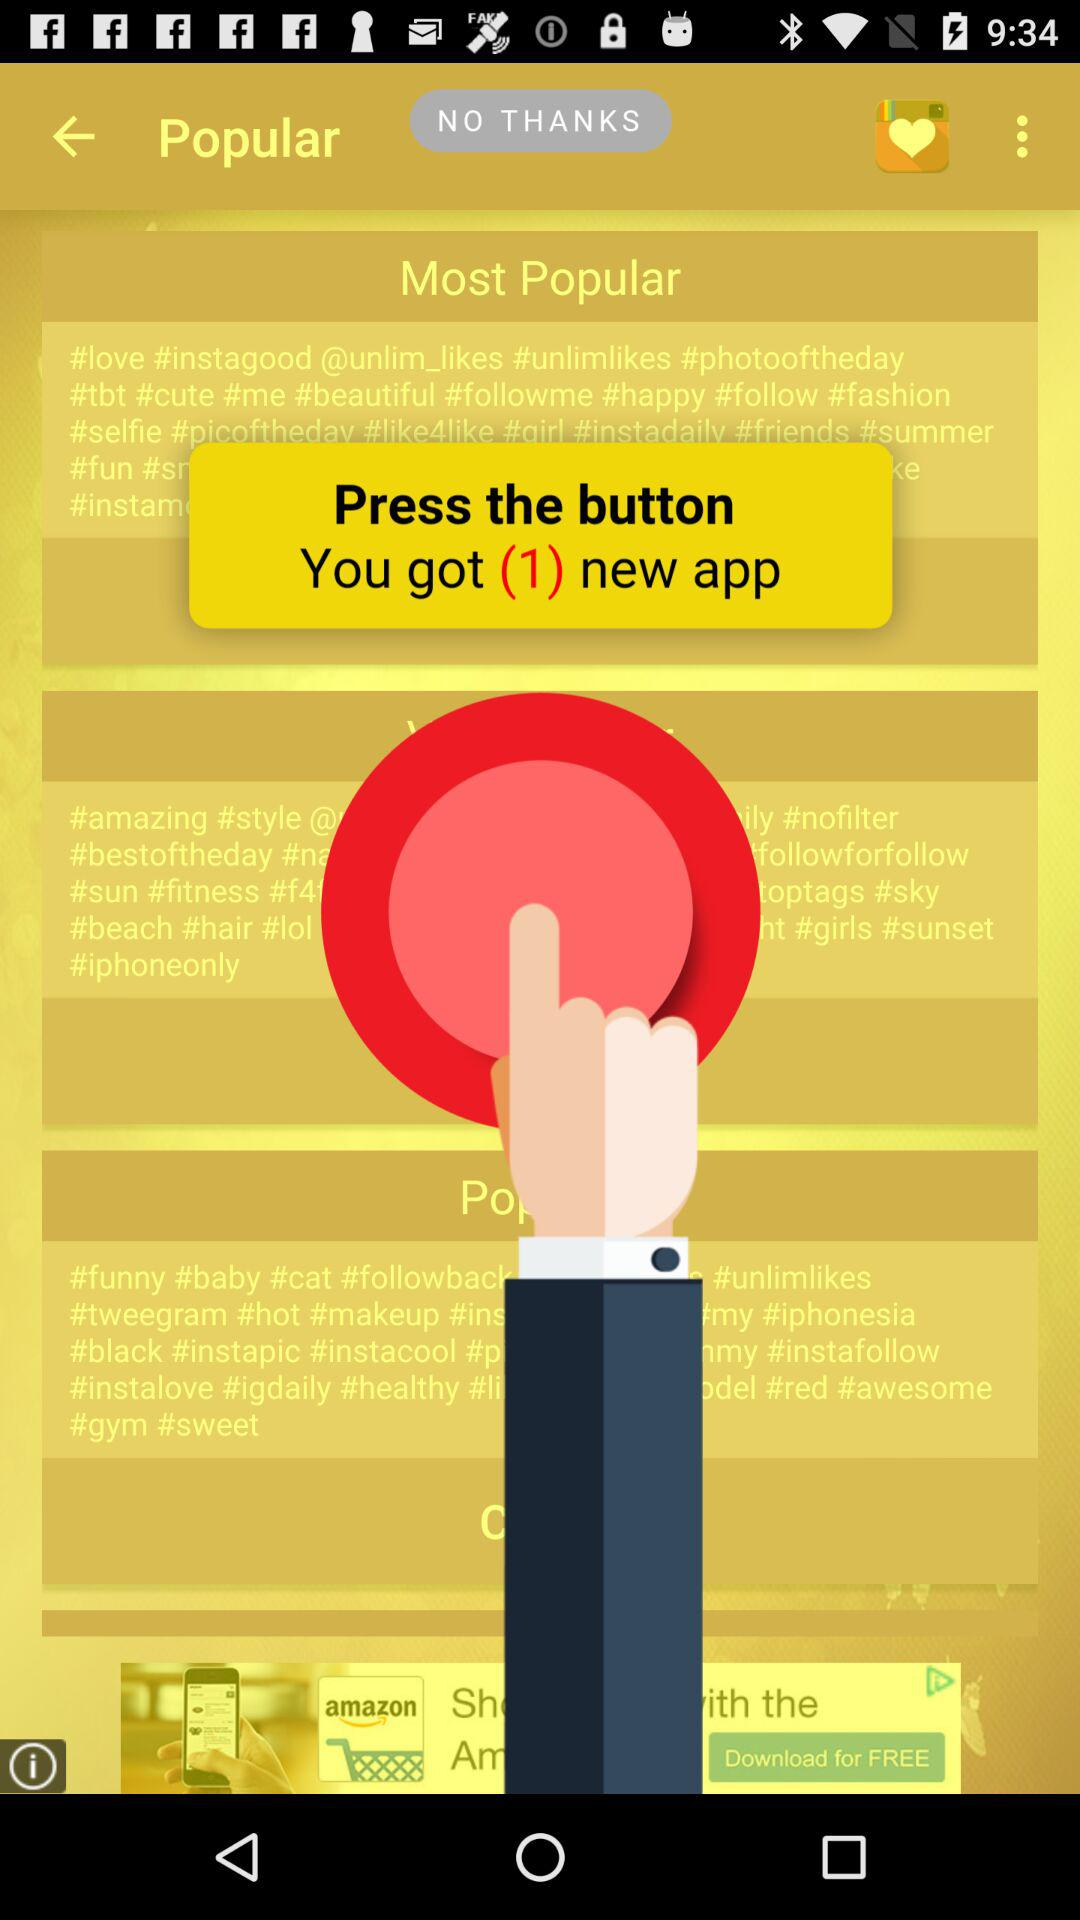When you press the button, how many apps will you get?
When the provided information is insufficient, respond with <no answer>. <no answer> 